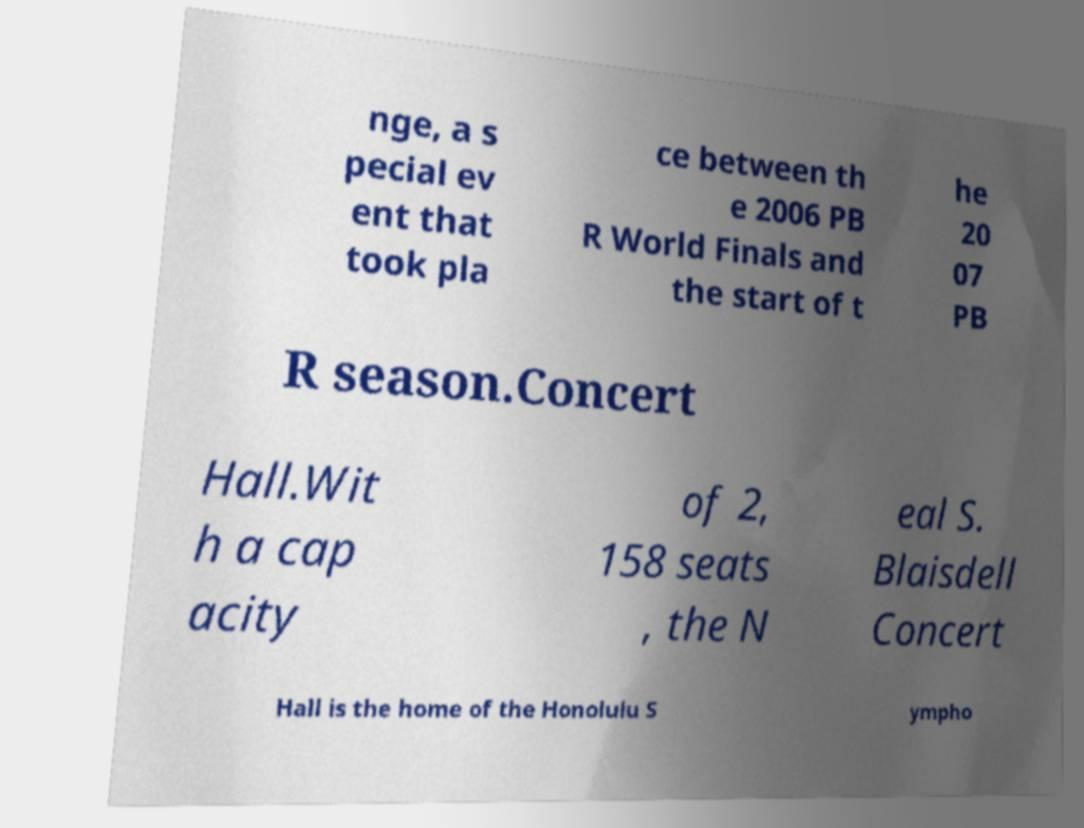What messages or text are displayed in this image? I need them in a readable, typed format. nge, a s pecial ev ent that took pla ce between th e 2006 PB R World Finals and the start of t he 20 07 PB R season.Concert Hall.Wit h a cap acity of 2, 158 seats , the N eal S. Blaisdell Concert Hall is the home of the Honolulu S ympho 